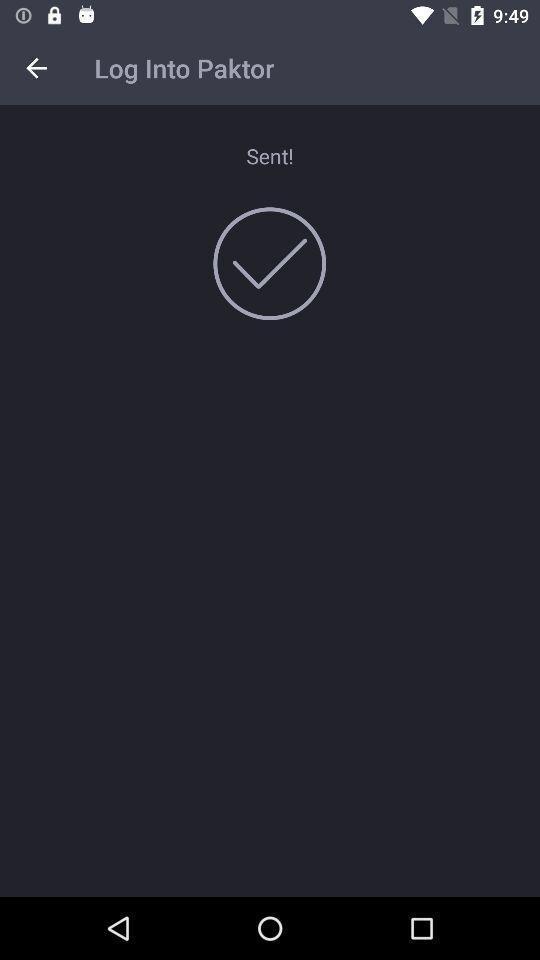Describe the content in this image. Screen shows log into paktor page. 